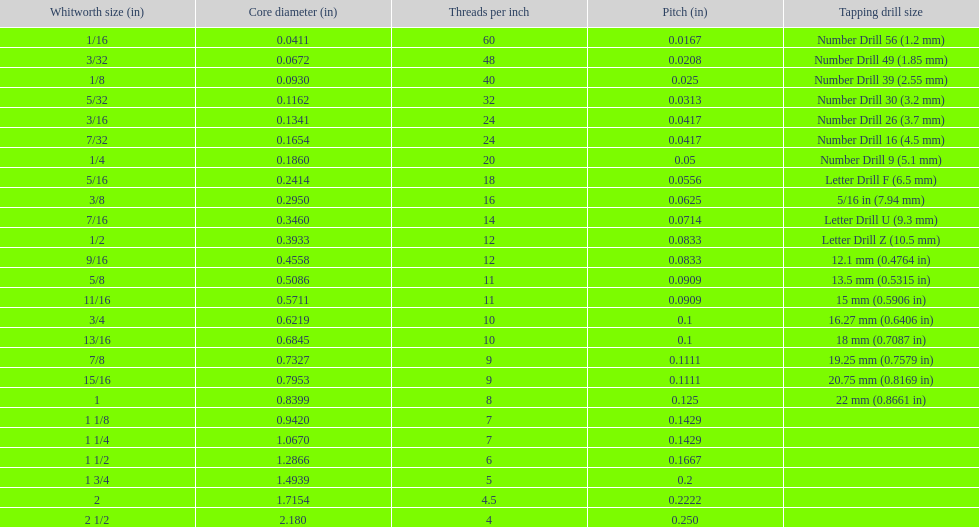How many threads per inch does a 9/16 have? 12. 